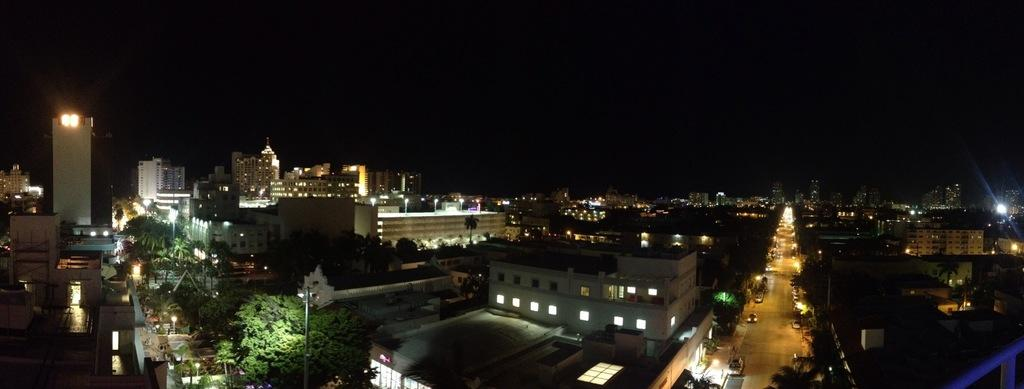What type of view is shown in the image? The image is a top view of a city. What natural elements can be seen in the image? There are trees in the image. What man-made structures are visible in the image? There are buildings in the image. What type of lighting is present in the image? There are lamp posts in the image. What type of transportation is visible in the image? There are vehicles on the roads in the image. What is the name of the arm that is visible in the image? There is no arm visible in the image; it is a top view of a city with no visible human elements. 